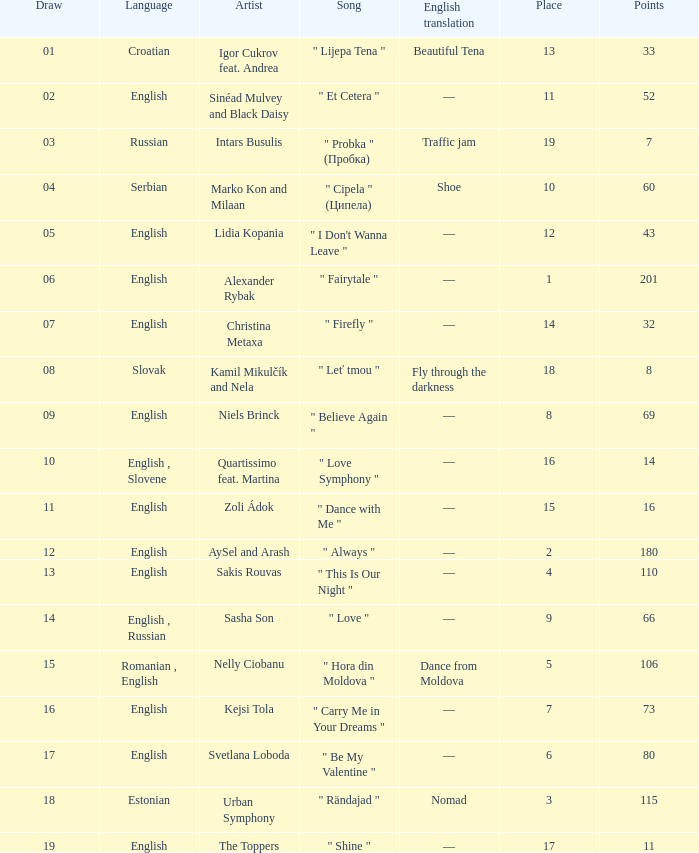What is the english translation when the language is english, draw is smaller than 16, and the artist is aysel and arash? —. 